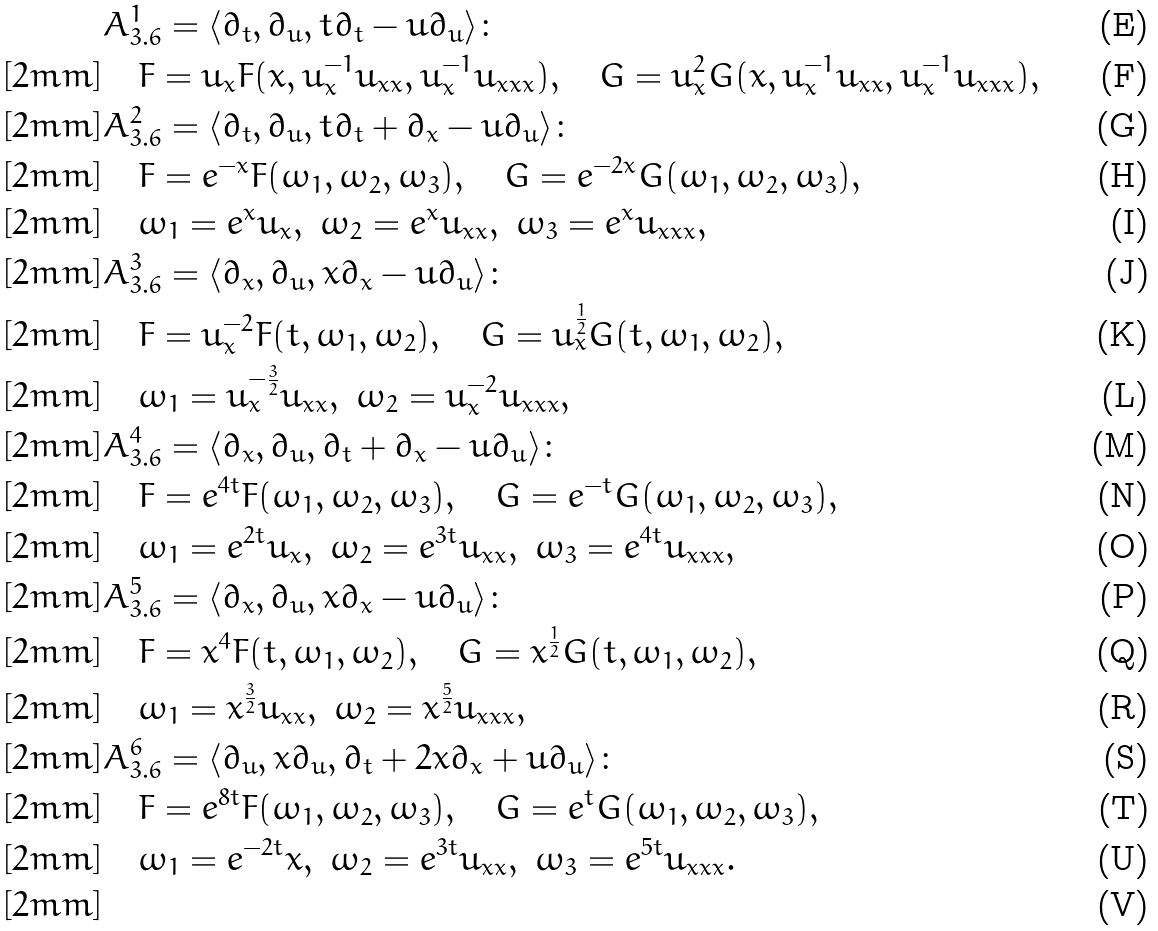Convert formula to latex. <formula><loc_0><loc_0><loc_500><loc_500>& A ^ { 1 } _ { 3 . 6 } = \langle \partial _ { t } , \partial _ { u } , t \partial _ { t } - u \partial _ { u } \rangle \colon \\ [ 2 m m ] & \quad F = u _ { x } F ( x , u _ { x } ^ { - 1 } u _ { x x } , u _ { x } ^ { - 1 } u _ { x x x } ) , \quad G = u _ { x } ^ { 2 } G ( x , u _ { x } ^ { - 1 } u _ { x x } , u _ { x } ^ { - 1 } u _ { x x x } ) , \\ [ 2 m m ] & A ^ { 2 } _ { 3 . 6 } = \langle \partial _ { t } , \partial _ { u } , t \partial _ { t } + \partial _ { x } - u \partial _ { u } \rangle \colon \\ [ 2 m m ] & \quad F = e ^ { - x } F ( \omega _ { 1 } , \omega _ { 2 } , \omega _ { 3 } ) , \quad G = e ^ { - 2 x } G ( \omega _ { 1 } , \omega _ { 2 } , \omega _ { 3 } ) , \\ [ 2 m m ] & \quad \omega _ { 1 } = e ^ { x } u _ { x } , \ \omega _ { 2 } = e ^ { x } u _ { x x } , \ \omega _ { 3 } = e ^ { x } u _ { x x x } , \\ [ 2 m m ] & A ^ { 3 } _ { 3 . 6 } = \langle \partial _ { x } , \partial _ { u } , x \partial _ { x } - u \partial _ { u } \rangle \colon \\ [ 2 m m ] & \quad F = u _ { x } ^ { - 2 } F ( t , \omega _ { 1 } , \omega _ { 2 } ) , \quad G = u _ { x } ^ { \frac { 1 } { 2 } } G ( t , \omega _ { 1 } , \omega _ { 2 } ) , \\ [ 2 m m ] & \quad \omega _ { 1 } = u _ { x } ^ { - \frac { 3 } { 2 } } u _ { x x } , \ \omega _ { 2 } = u _ { x } ^ { - 2 } u _ { x x x } , \\ [ 2 m m ] & A ^ { 4 } _ { 3 . 6 } = \langle \partial _ { x } , \partial _ { u } , \partial _ { t } + \partial _ { x } - u \partial _ { u } \rangle \colon \\ [ 2 m m ] & \quad F = e ^ { 4 t } F ( \omega _ { 1 } , \omega _ { 2 } , \omega _ { 3 } ) , \quad G = e ^ { - t } G ( \omega _ { 1 } , \omega _ { 2 } , \omega _ { 3 } ) , \\ [ 2 m m ] & \quad \omega _ { 1 } = e ^ { 2 t } u _ { x } , \ \omega _ { 2 } = e ^ { 3 t } u _ { x x } , \ \omega _ { 3 } = e ^ { 4 t } u _ { x x x } , \\ [ 2 m m ] & A ^ { 5 } _ { 3 . 6 } = \langle \partial _ { x } , \partial _ { u } , x \partial _ { x } - u \partial _ { u } \rangle \colon \\ [ 2 m m ] & \quad F = x ^ { 4 } F ( t , \omega _ { 1 } , \omega _ { 2 } ) , \quad G = x ^ { \frac { 1 } { 2 } } G ( t , \omega _ { 1 } , \omega _ { 2 } ) , \\ [ 2 m m ] & \quad \omega _ { 1 } = x ^ { \frac { 3 } { 2 } } u _ { x x } , \ \omega _ { 2 } = x ^ { \frac { 5 } { 2 } } u _ { x x x } , \\ [ 2 m m ] & A ^ { 6 } _ { 3 . 6 } = \langle \partial _ { u } , x \partial _ { u } , \partial _ { t } + 2 x \partial _ { x } + u \partial _ { u } \rangle \colon \\ [ 2 m m ] & \quad F = e ^ { 8 t } F ( \omega _ { 1 } , \omega _ { 2 } , \omega _ { 3 } ) , \quad G = e ^ { t } G ( \omega _ { 1 } , \omega _ { 2 } , \omega _ { 3 } ) , \\ [ 2 m m ] & \quad \omega _ { 1 } = e ^ { - 2 t } x , \ \omega _ { 2 } = e ^ { 3 t } u _ { x x } , \ \omega _ { 3 } = e ^ { 5 t } u _ { x x x } . \\ [ 2 m m ]</formula> 